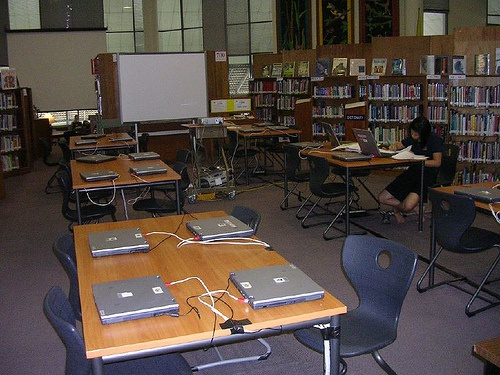Describe the objects in this image and their specific colors. I can see book in black, gray, and maroon tones, chair in black, gray, and darkblue tones, chair in black and gray tones, laptop in black and gray tones, and chair in black, navy, and purple tones in this image. 